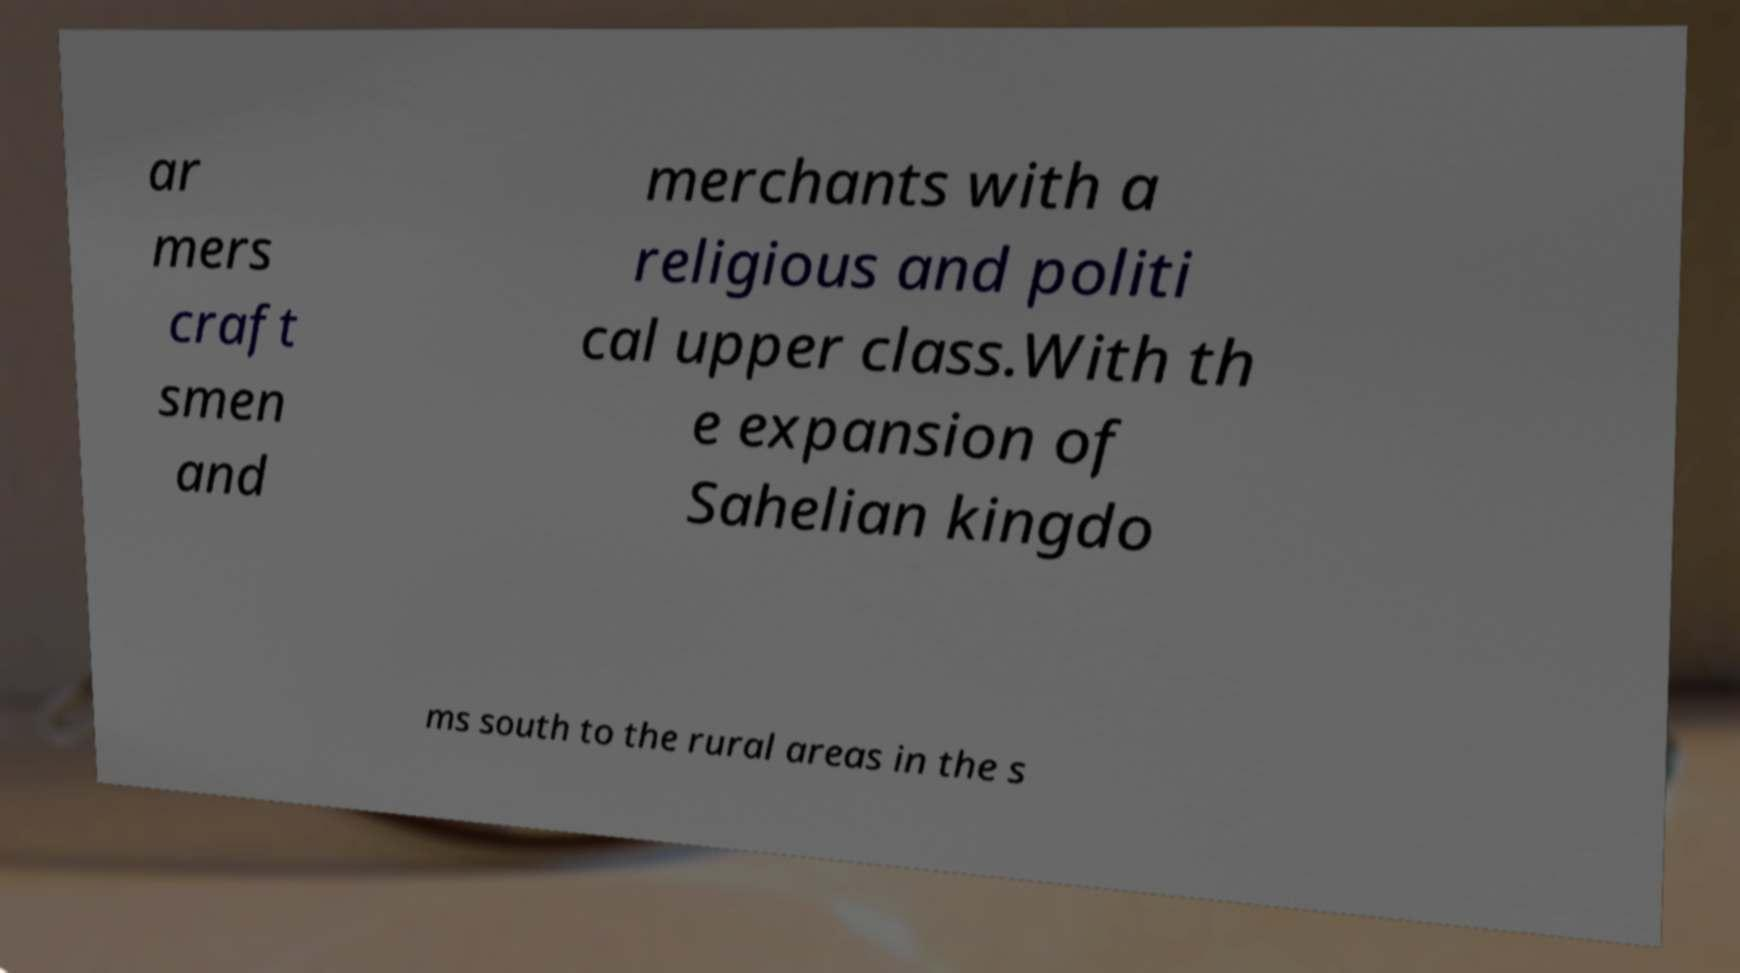Please identify and transcribe the text found in this image. ar mers craft smen and merchants with a religious and politi cal upper class.With th e expansion of Sahelian kingdo ms south to the rural areas in the s 